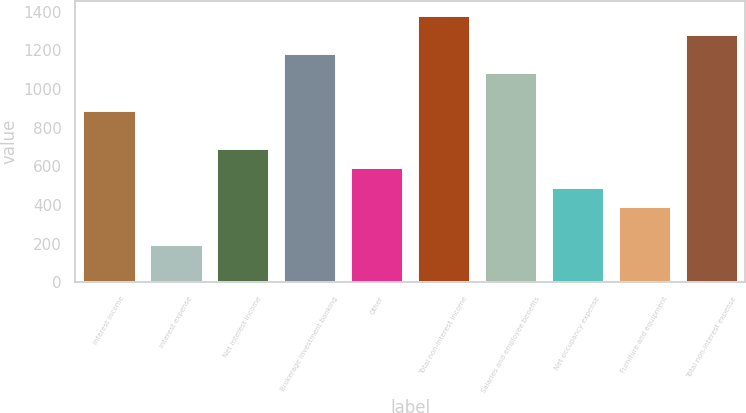Convert chart to OTSL. <chart><loc_0><loc_0><loc_500><loc_500><bar_chart><fcel>Interest income<fcel>Interest expense<fcel>Net interest income<fcel>Brokerage investment banking<fcel>Other<fcel>Total non-interest income<fcel>Salaries and employee benefits<fcel>Net occupancy expense<fcel>Furniture and equipment<fcel>Total non-interest expense<nl><fcel>891.04<fcel>198.04<fcel>693.04<fcel>1188.04<fcel>594.04<fcel>1386.04<fcel>1089.04<fcel>495.04<fcel>396.04<fcel>1287.04<nl></chart> 